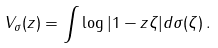Convert formula to latex. <formula><loc_0><loc_0><loc_500><loc_500>V _ { \sigma } ( z ) = \int \log | 1 - z \zeta | d \sigma ( \zeta ) \, .</formula> 